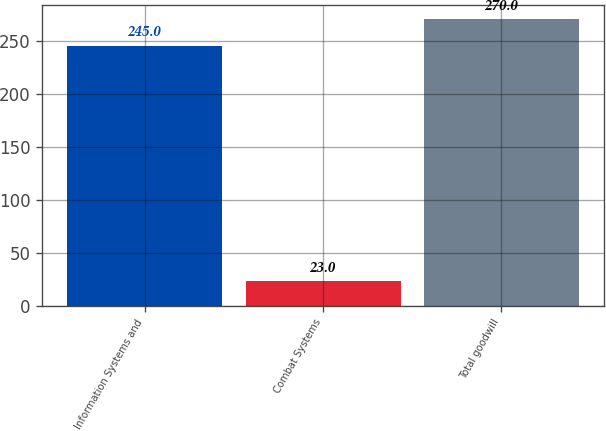Convert chart to OTSL. <chart><loc_0><loc_0><loc_500><loc_500><bar_chart><fcel>Information Systems and<fcel>Combat Systems<fcel>Total goodwill<nl><fcel>245<fcel>23<fcel>270<nl></chart> 